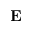<formula> <loc_0><loc_0><loc_500><loc_500>E</formula> 